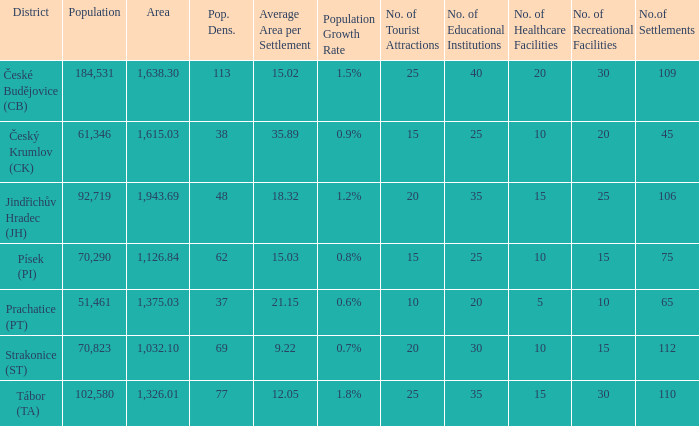How big is the area that has a population density of 113 and a population larger than 184,531? 0.0. 